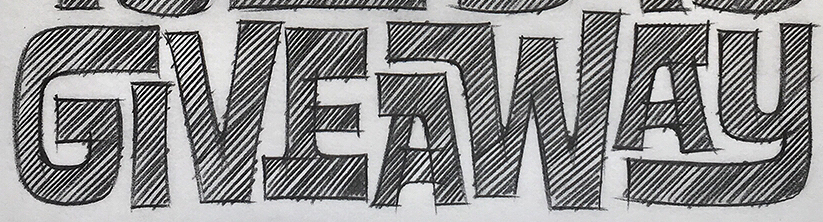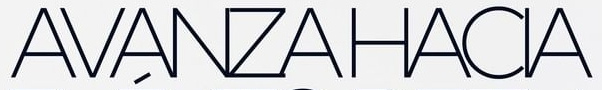Read the text content from these images in order, separated by a semicolon. GIVEAWAY; AVANZAHACIA 